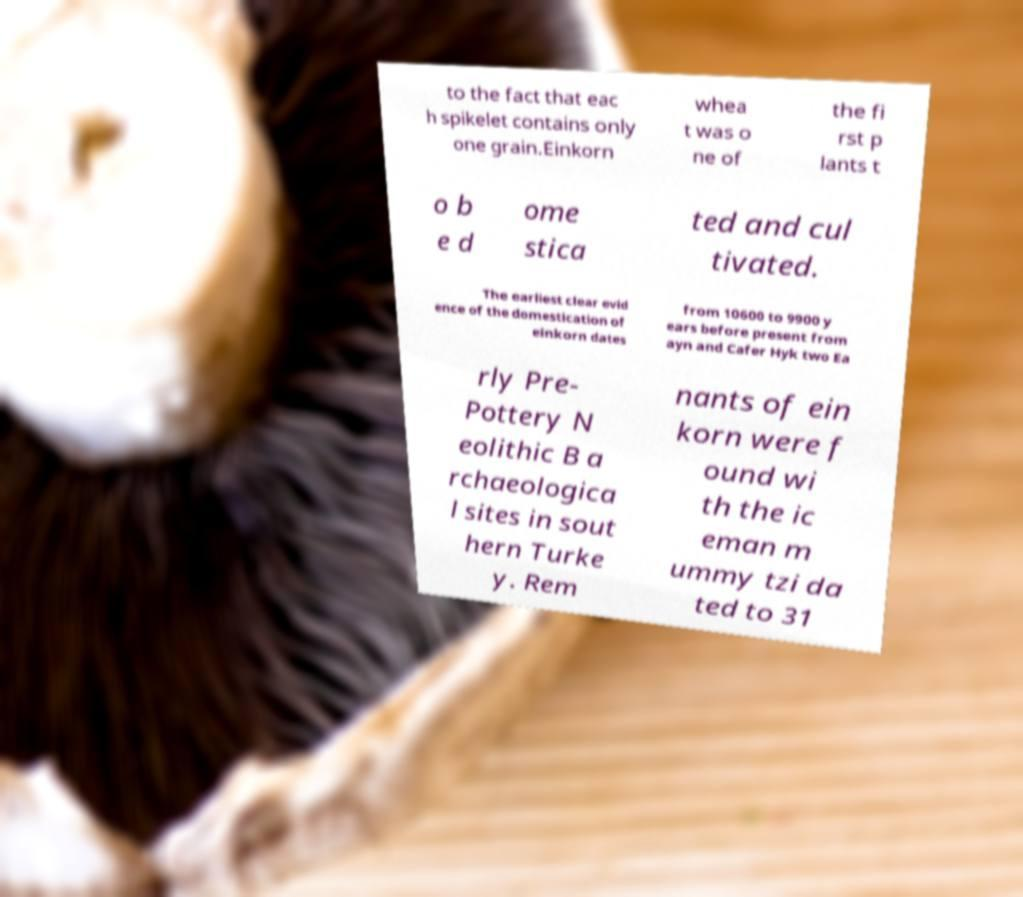Could you extract and type out the text from this image? to the fact that eac h spikelet contains only one grain.Einkorn whea t was o ne of the fi rst p lants t o b e d ome stica ted and cul tivated. The earliest clear evid ence of the domestication of einkorn dates from 10600 to 9900 y ears before present from ayn and Cafer Hyk two Ea rly Pre- Pottery N eolithic B a rchaeologica l sites in sout hern Turke y. Rem nants of ein korn were f ound wi th the ic eman m ummy tzi da ted to 31 